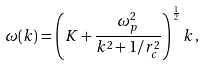Convert formula to latex. <formula><loc_0><loc_0><loc_500><loc_500>\omega ( k ) = \left ( K + \frac { \omega _ { p } ^ { 2 } } { k ^ { 2 } + 1 / r _ { c } ^ { 2 } } \right ) ^ { \frac { 1 } { 2 } } k \, ,</formula> 